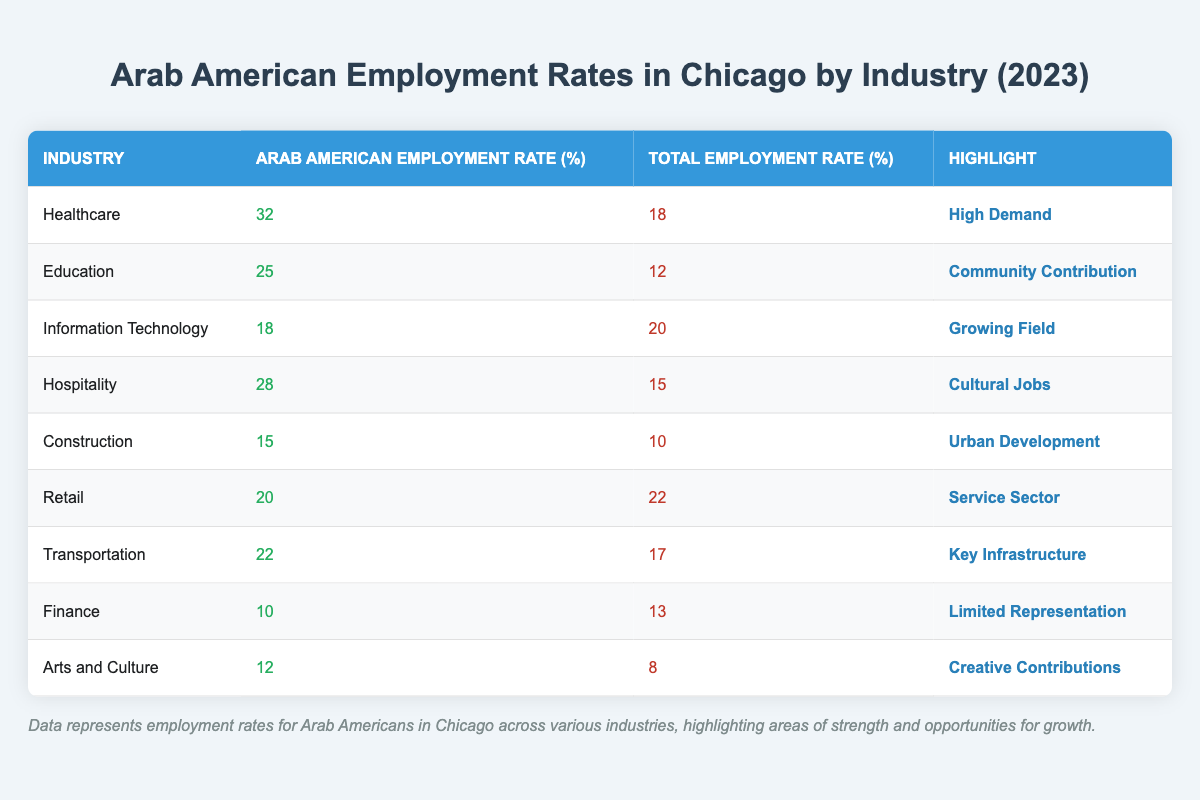What is the Arab American employment rate in Healthcare? The table lists the Arab American employment rate in Healthcare as 32%.
Answer: 32% Which industry has the highest Arab American employment rate? The Healthcare industry has the highest Arab American employment rate at 32%.
Answer: Healthcare What is the Total Employment Rate in the Retail industry? The Total Employment Rate in the Retail industry is 22%.
Answer: 22% Is the employment rate for Arab Americans higher in the Education industry compared to the Total Employment Rate? The Arab American employment rate in Education is 25%, while the Total Employment Rate is 12%, which means it is higher.
Answer: Yes What is the difference between the Arab American employment rate in Hospitality and the Total Employment Rate in the same industry? The Arab American employment rate in Hospitality is 28%, and the Total Employment Rate is 15%. The difference is 28% - 15% = 13%.
Answer: 13% What is the average Arab American employment rate across all industries listed in the table? To find the average, sum the Arab American employment rates: 32 + 25 + 18 + 28 + 15 + 20 + 22 + 10 + 12 =  252. There are 9 industries, so the average is 252 / 9 = 28.
Answer: 28 Which industry has the lowest Arab American employment rate and what is it? The Finance industry has the lowest Arab American employment rate at 10%.
Answer: Finance, 10% Are there more industries where the Arab American employment rate is higher than the Total Employment Rate than those where it is lower? There are five industries where the Arab American employment rate is higher than the Total Employment Rate (Healthcare, Education, Hospitality, Transportation, Retail) and four where it is lower (Information Technology, Construction, Finance, Arts and Culture), so there are more industries higher.
Answer: Yes What is the total of Arab American employment rates in the sectors related to community development (Healthcare, Education, and Transportation)? The Arab American employment rates are 32% (Healthcare) + 25% (Education) + 22% (Transportation) = 79%.
Answer: 79% Is the Arab American employment rate in Information Technology greater than the Total Employment Rate in the same field? The Arab American employment rate in Information Technology is 18%, whereas the Total Employment Rate is 20%, indicating it is not greater.
Answer: No 